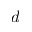Convert formula to latex. <formula><loc_0><loc_0><loc_500><loc_500>d</formula> 